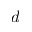Convert formula to latex. <formula><loc_0><loc_0><loc_500><loc_500>d</formula> 